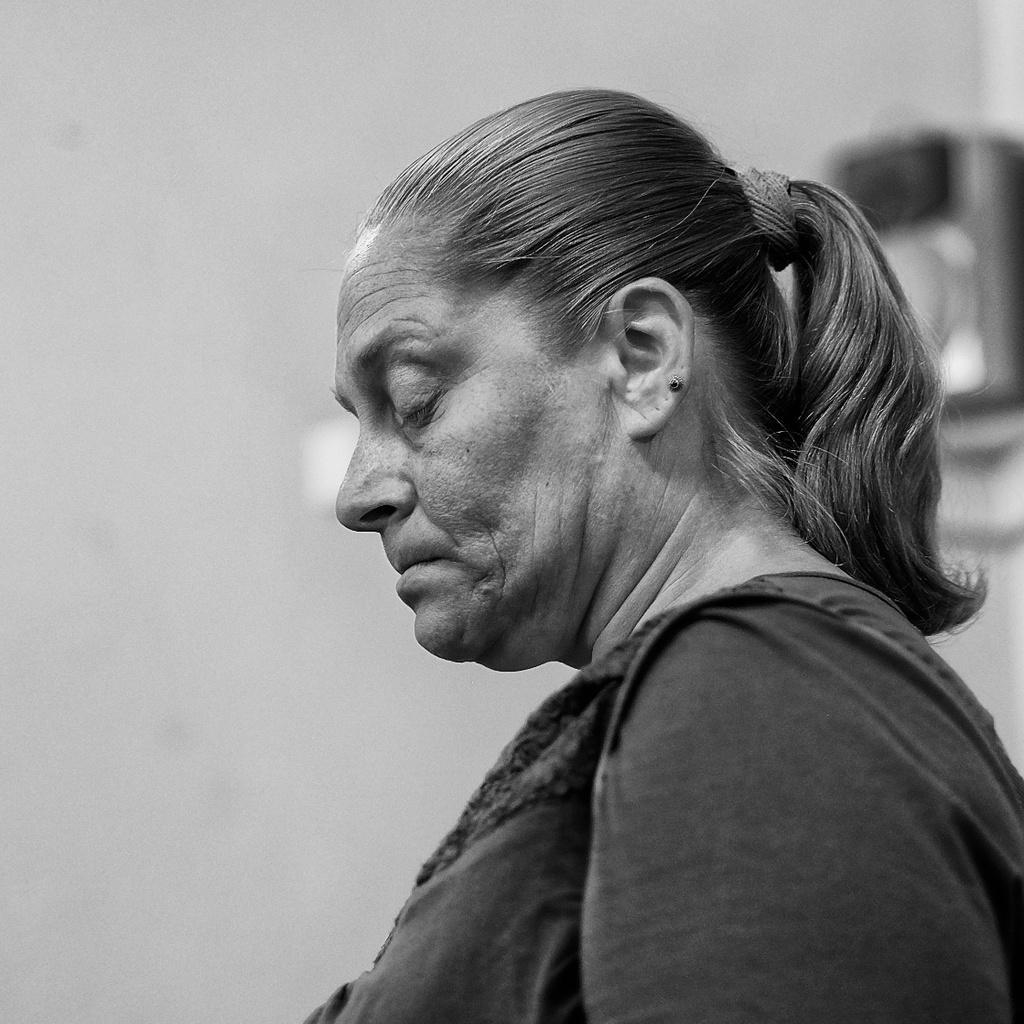Could you give a brief overview of what you see in this image? In this image in the foreground there is one women, and in the background there is a wall and some objects. 